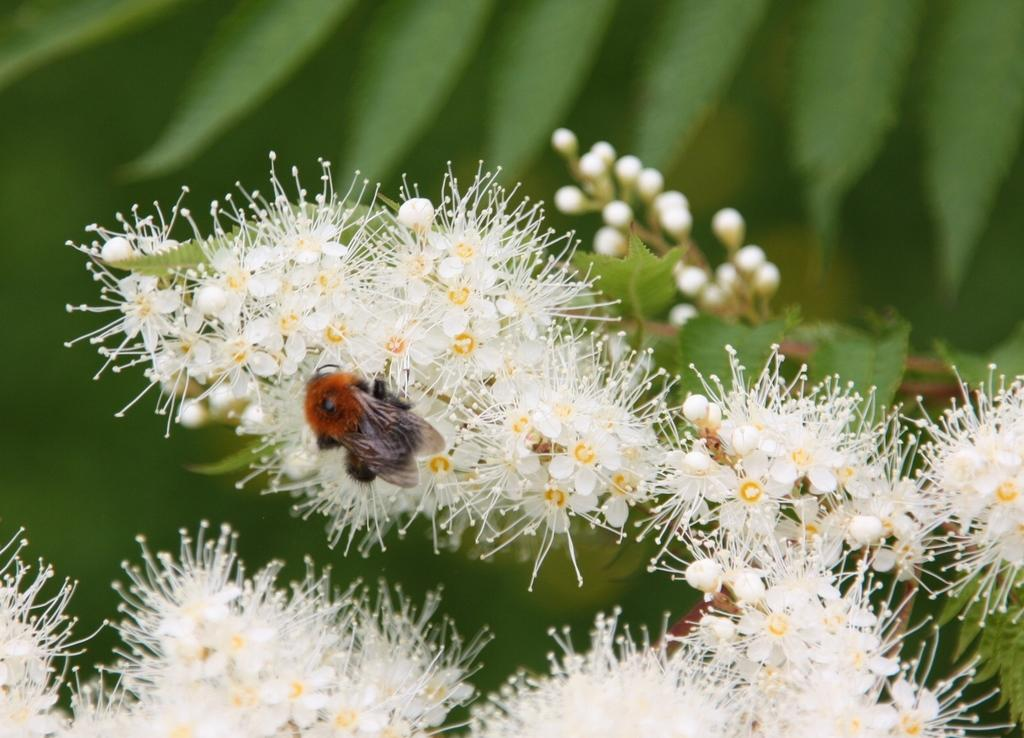What type of flowers are present in the image? There are white flowers in the image. What stage of growth are the flowers in? The flowers have buds on them. Is there any other living organism present on the flowers? Yes, there is an insect on one of the flowers. What color is the background of the image? The background of the image is green. What type of addition problem can be solved using the flowers in the image? There is no addition problem present in the image, as it features flowers and an insect. Can you tell me how many ladybugs are on the flowers in the image? There is no ladybug present in the image; only an insect is visible. 